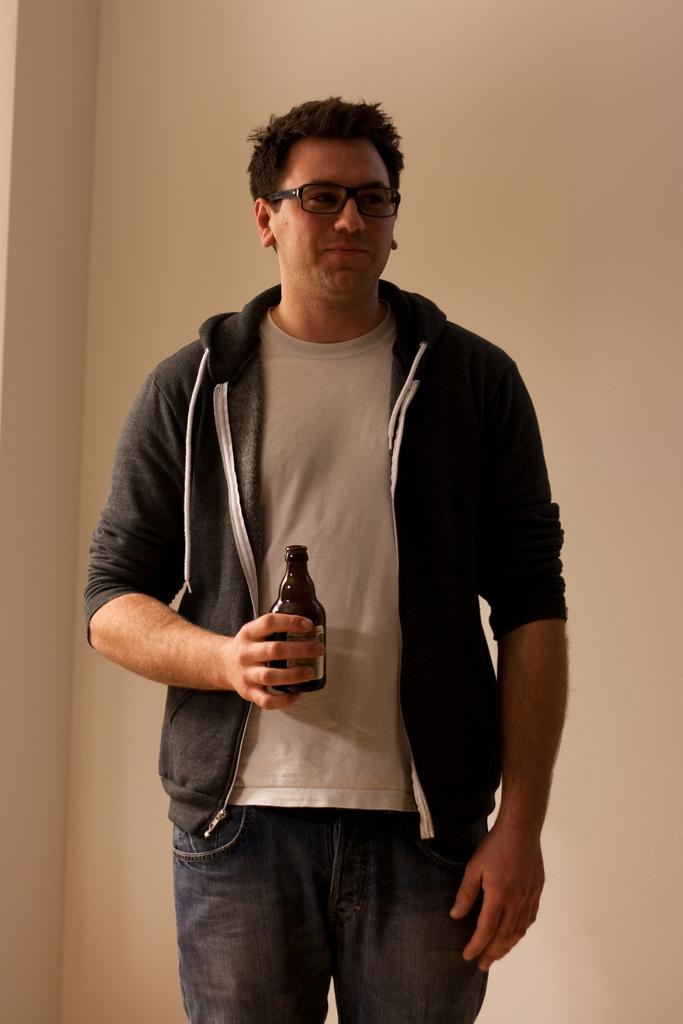Who is present in the image? There is a man in the picture. What is the man wearing? The man is wearing a black jacket. What is the man holding in his right hand? The man is holding a bottle in his right hand. Where is the nest located in the image? There is no nest present in the image. What type of bean is visible in the man's hand? The man is holding a bottle, not a bean, in his right hand. 